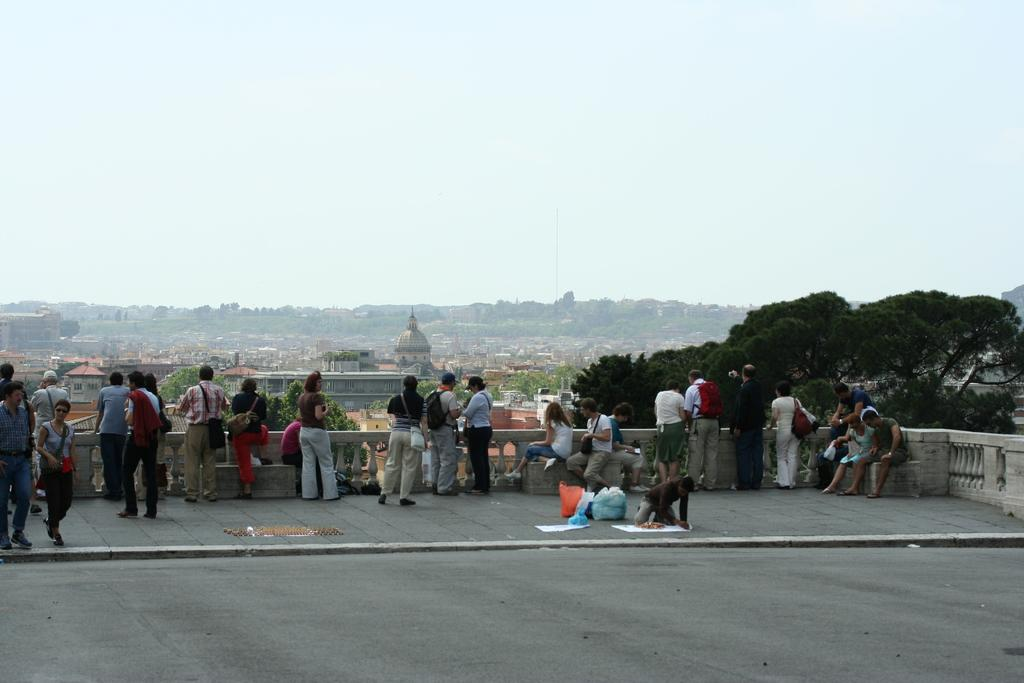What can be seen in the image? There are people standing in the image. Where are the people standing? The people are standing on the floor. What can be seen in the background of the image? There are trees, houses, and the clear sky visible in the background. What type of potato is being used as a cap by one of the people in the image? There is no potato or cap present in the image; the people are not wearing any headgear. What color are the trousers worn by the people in the image? The provided facts do not mention the color or type of clothing worn by the people in the image. 